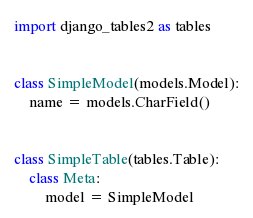<code> <loc_0><loc_0><loc_500><loc_500><_Python_>import django_tables2 as tables


class SimpleModel(models.Model):
    name = models.CharField()


class SimpleTable(tables.Table):
    class Meta:
        model = SimpleModel
</code> 